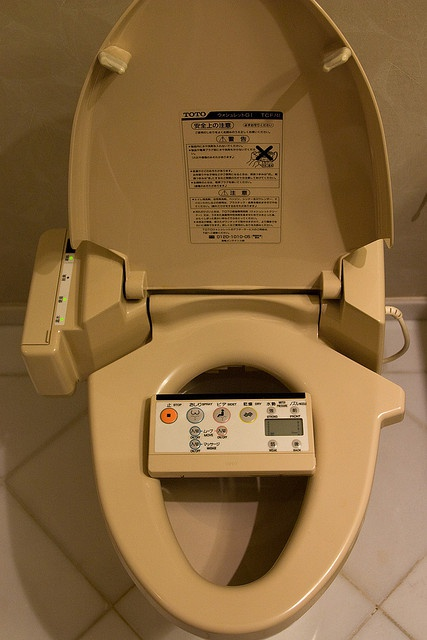Describe the objects in this image and their specific colors. I can see a toilet in maroon, olive, and tan tones in this image. 